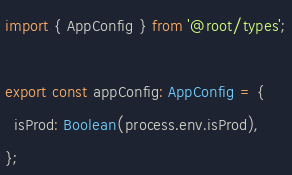Convert code to text. <code><loc_0><loc_0><loc_500><loc_500><_TypeScript_>import { AppConfig } from '@root/types';

export const appConfig: AppConfig = {
  isProd: Boolean(process.env.isProd),
};
</code> 